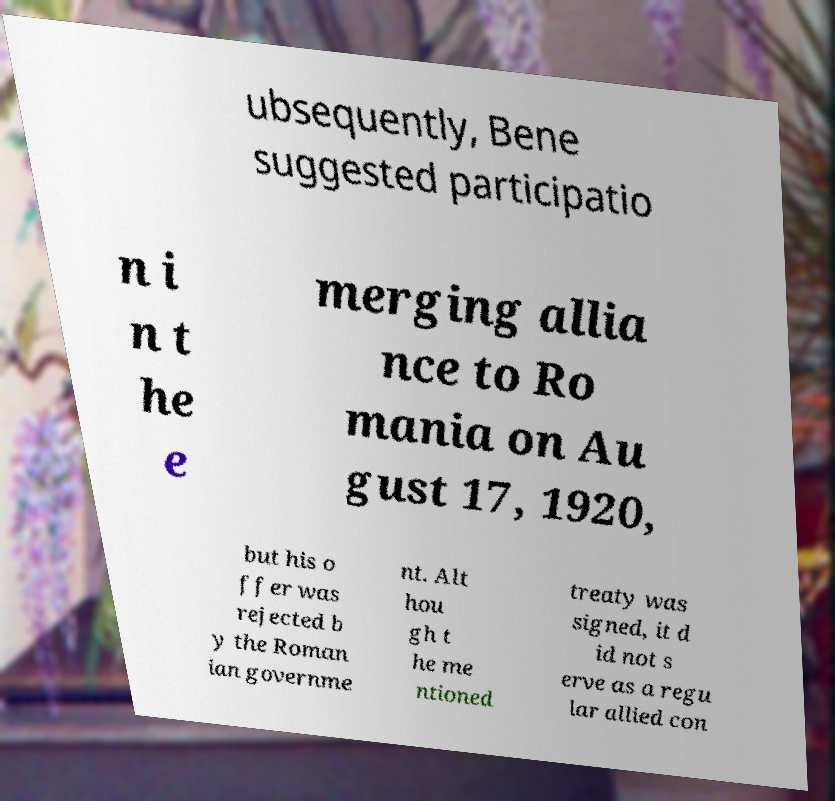Could you assist in decoding the text presented in this image and type it out clearly? ubsequently, Bene suggested participatio n i n t he e merging allia nce to Ro mania on Au gust 17, 1920, but his o ffer was rejected b y the Roman ian governme nt. Alt hou gh t he me ntioned treaty was signed, it d id not s erve as a regu lar allied con 